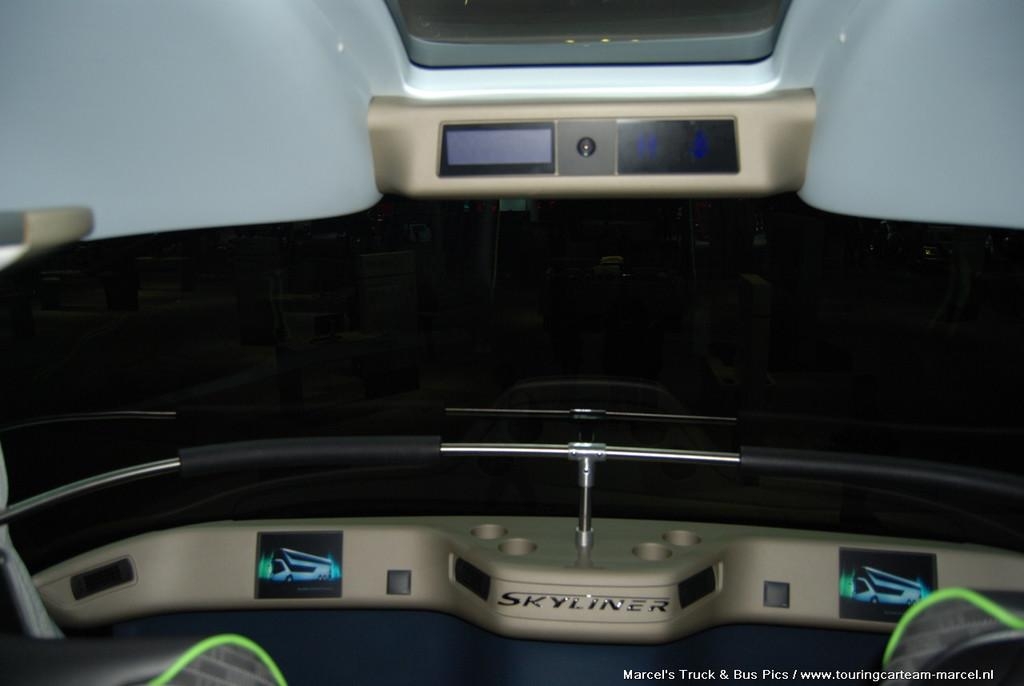What type of setting is depicted in the image? The image shows the inside view of a vehicle. What type of leaf is used as a veil in the image? There is no leaf or veil present in the image; it shows the inside view of a vehicle. 